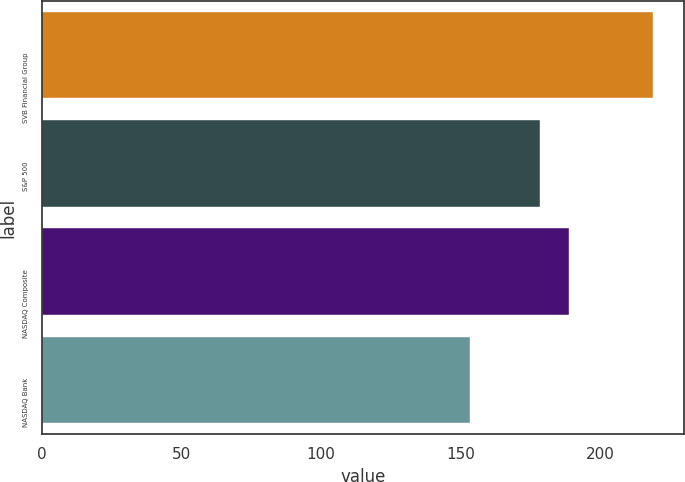Convert chart to OTSL. <chart><loc_0><loc_0><loc_500><loc_500><bar_chart><fcel>SVB Financial Group<fcel>S&P 500<fcel>NASDAQ Composite<fcel>NASDAQ Bank<nl><fcel>218.79<fcel>178.29<fcel>188.78<fcel>153.18<nl></chart> 